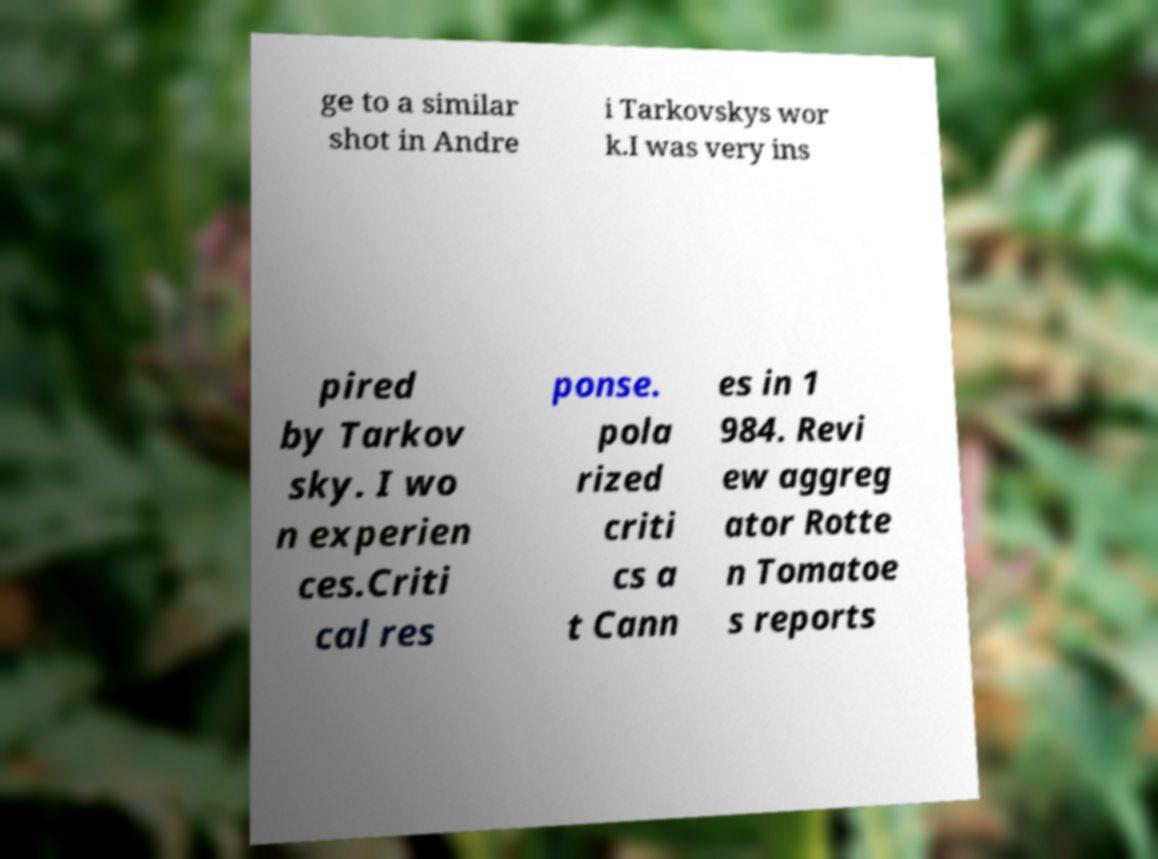For documentation purposes, I need the text within this image transcribed. Could you provide that? ge to a similar shot in Andre i Tarkovskys wor k.I was very ins pired by Tarkov sky. I wo n experien ces.Criti cal res ponse. pola rized criti cs a t Cann es in 1 984. Revi ew aggreg ator Rotte n Tomatoe s reports 